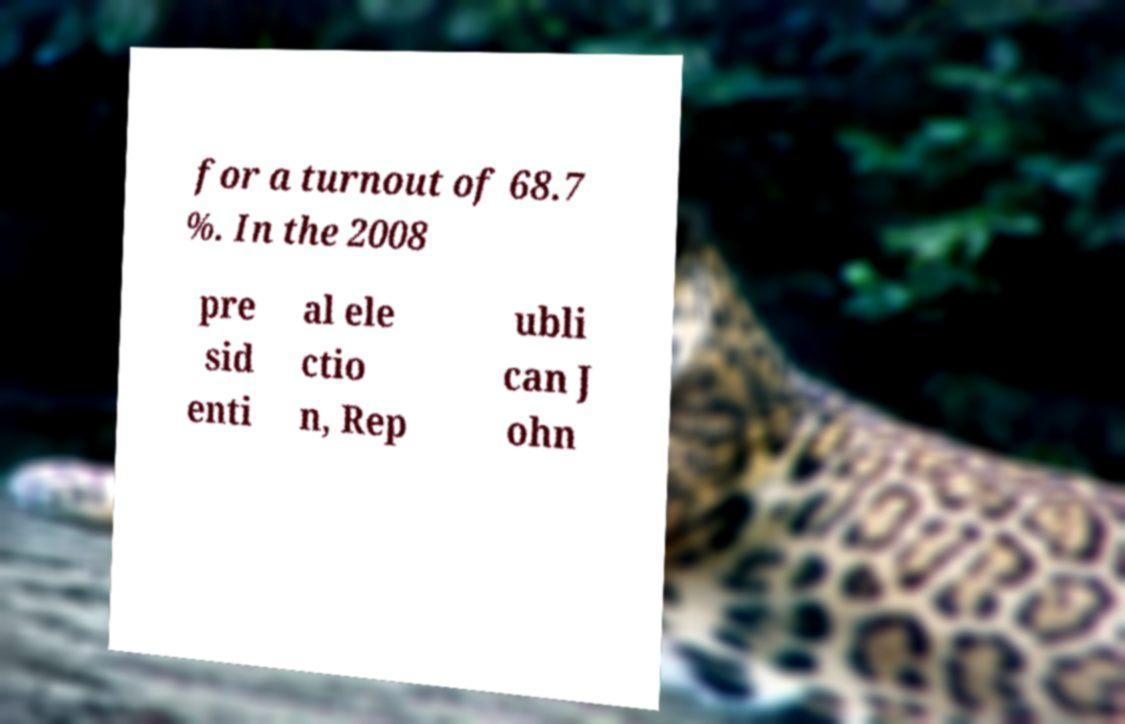Could you extract and type out the text from this image? for a turnout of 68.7 %. In the 2008 pre sid enti al ele ctio n, Rep ubli can J ohn 